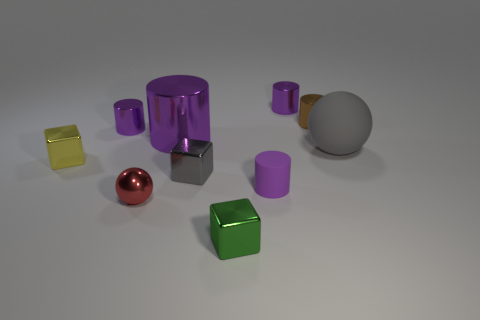Subtract all purple blocks. How many purple cylinders are left? 4 Subtract 1 cylinders. How many cylinders are left? 4 Subtract all brown cylinders. How many cylinders are left? 4 Subtract all big purple cylinders. How many cylinders are left? 4 Subtract all cyan cylinders. Subtract all brown spheres. How many cylinders are left? 5 Subtract all spheres. How many objects are left? 8 Subtract 0 blue cubes. How many objects are left? 10 Subtract all small green shiny blocks. Subtract all large yellow shiny blocks. How many objects are left? 9 Add 8 small brown shiny cylinders. How many small brown shiny cylinders are left? 9 Add 4 small green blocks. How many small green blocks exist? 5 